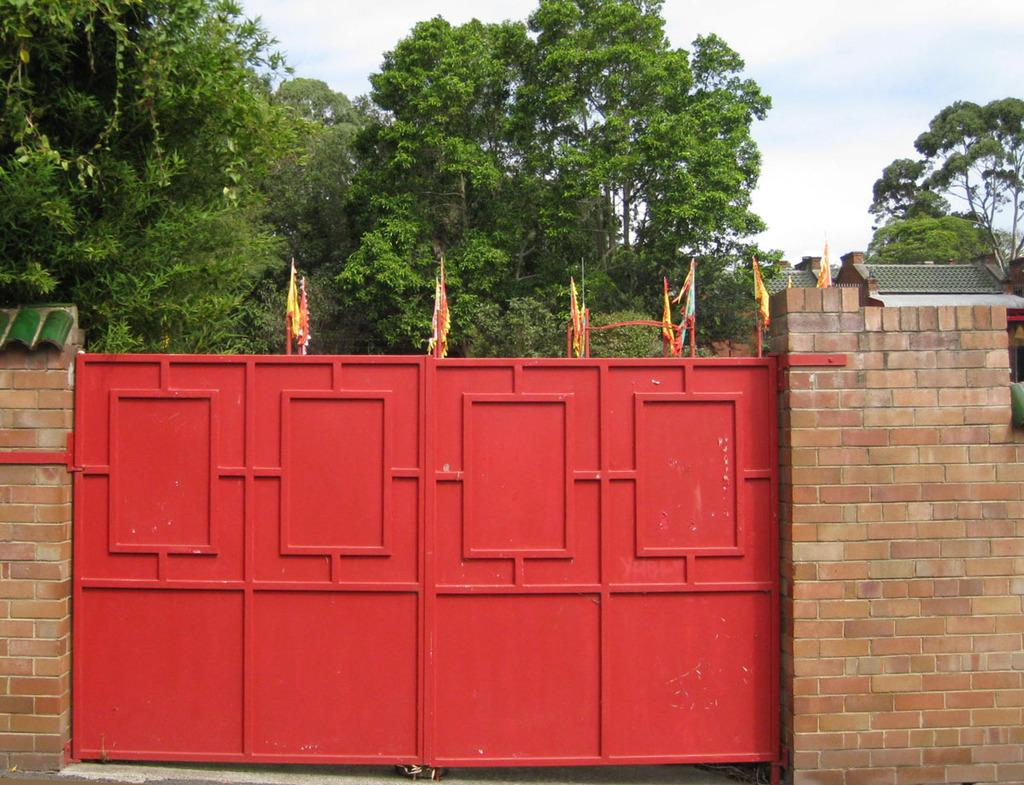What is the main object in the center of the image? There is a red color gate in the center of the image. What decorations are on the gate? Small flags are present on the gate. What can be seen in the background of the image? There are trees and a house in the background of the image. Is there a beggar asking for alms near the gate in the image? There is no beggar present in the image. Can you see a ghost floating around the gate in the image? There is no ghost present in the image. 